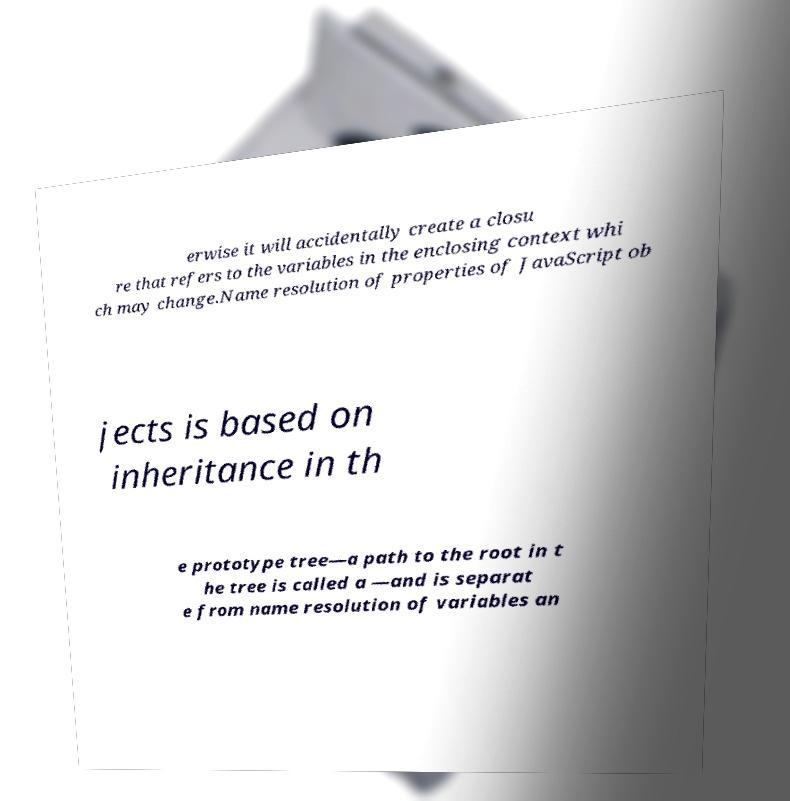Can you explain what a 'closure' in JavaScript is, as mentioned in the text? A closure in JavaScript is a powerful feature where a function is able to remember and access its lexical scope even when the function is executing outside its original scope. It makes it possible for a function to have 'private' variables. The function can access these variables, but they cannot be directly accessed from outside the function. 